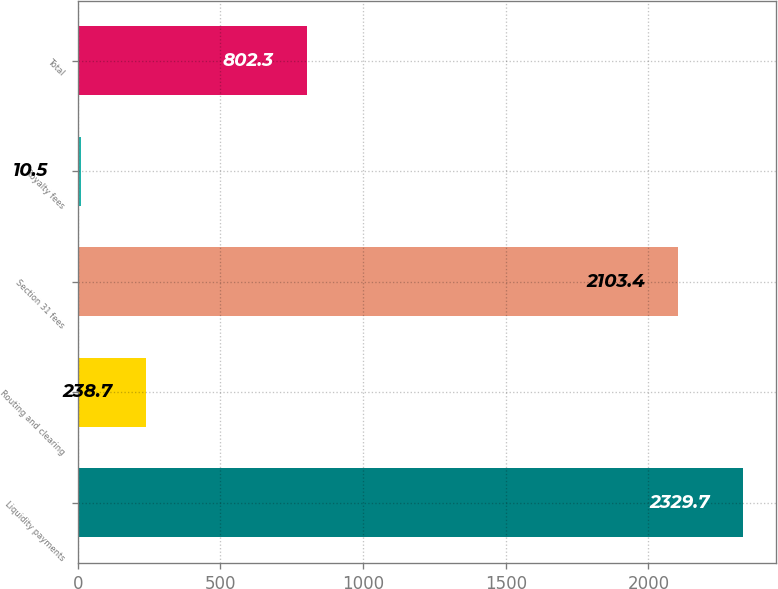Convert chart to OTSL. <chart><loc_0><loc_0><loc_500><loc_500><bar_chart><fcel>Liquidity payments<fcel>Routing and clearing<fcel>Section 31 fees<fcel>Royalty fees<fcel>Total<nl><fcel>2329.7<fcel>238.7<fcel>2103.4<fcel>10.5<fcel>802.3<nl></chart> 